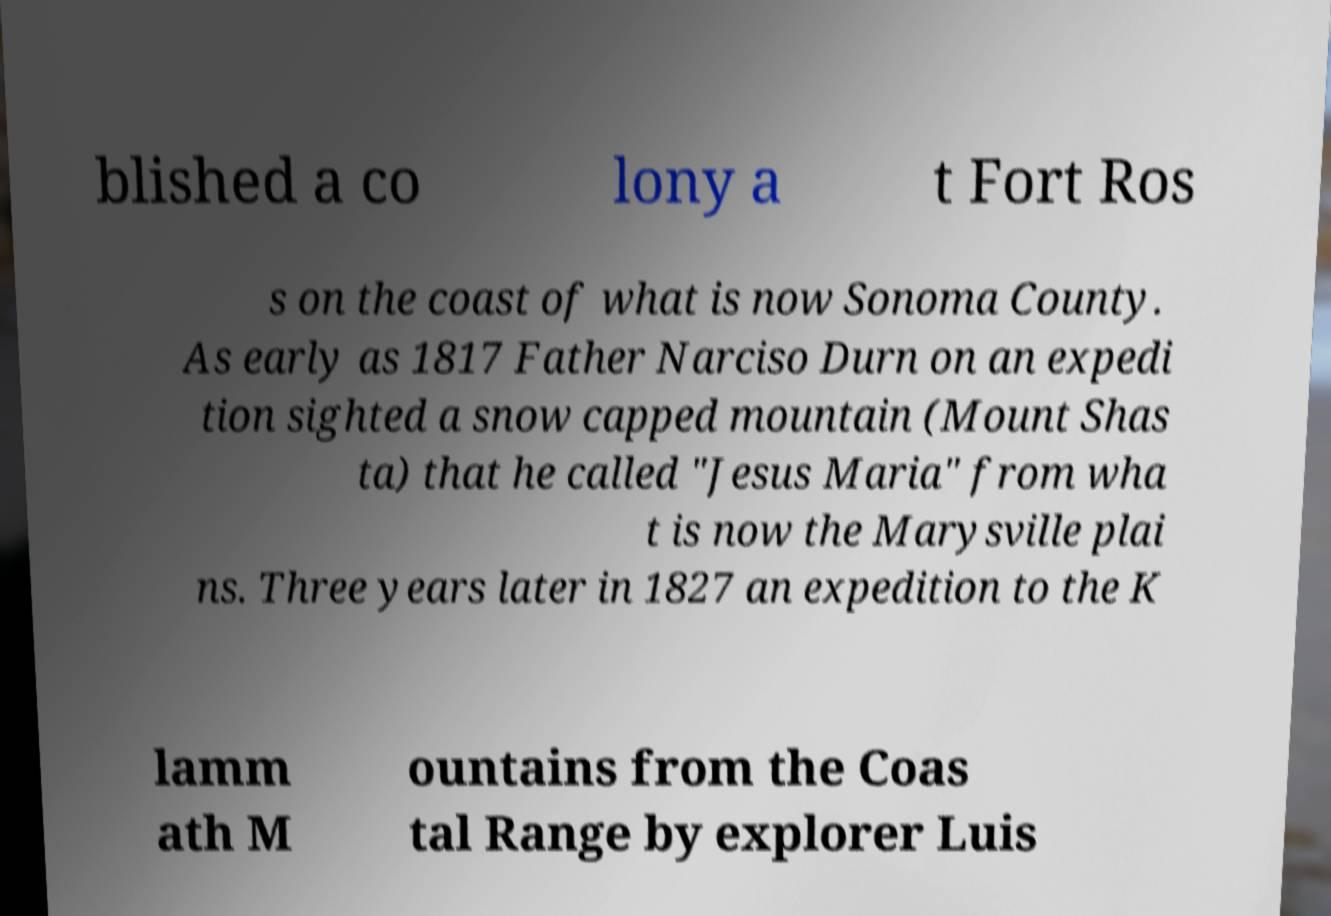Can you accurately transcribe the text from the provided image for me? blished a co lony a t Fort Ros s on the coast of what is now Sonoma County. As early as 1817 Father Narciso Durn on an expedi tion sighted a snow capped mountain (Mount Shas ta) that he called "Jesus Maria" from wha t is now the Marysville plai ns. Three years later in 1827 an expedition to the K lamm ath M ountains from the Coas tal Range by explorer Luis 